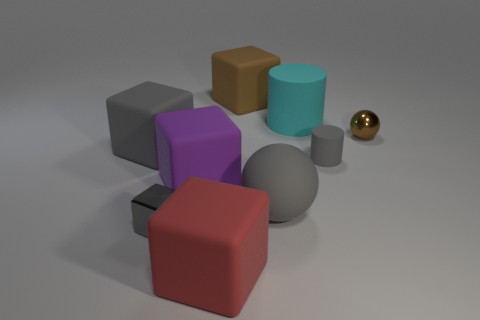Subtract all matte cubes. How many cubes are left? 1 Subtract 1 cubes. How many cubes are left? 4 Subtract all brown cubes. How many cubes are left? 4 Add 1 purple things. How many objects exist? 10 Subtract all cyan cubes. Subtract all gray cylinders. How many cubes are left? 5 Subtract all cubes. How many objects are left? 4 Subtract 1 red blocks. How many objects are left? 8 Subtract all tiny gray blocks. Subtract all purple rubber things. How many objects are left? 7 Add 7 big cyan matte cylinders. How many big cyan matte cylinders are left? 8 Add 3 gray matte objects. How many gray matte objects exist? 6 